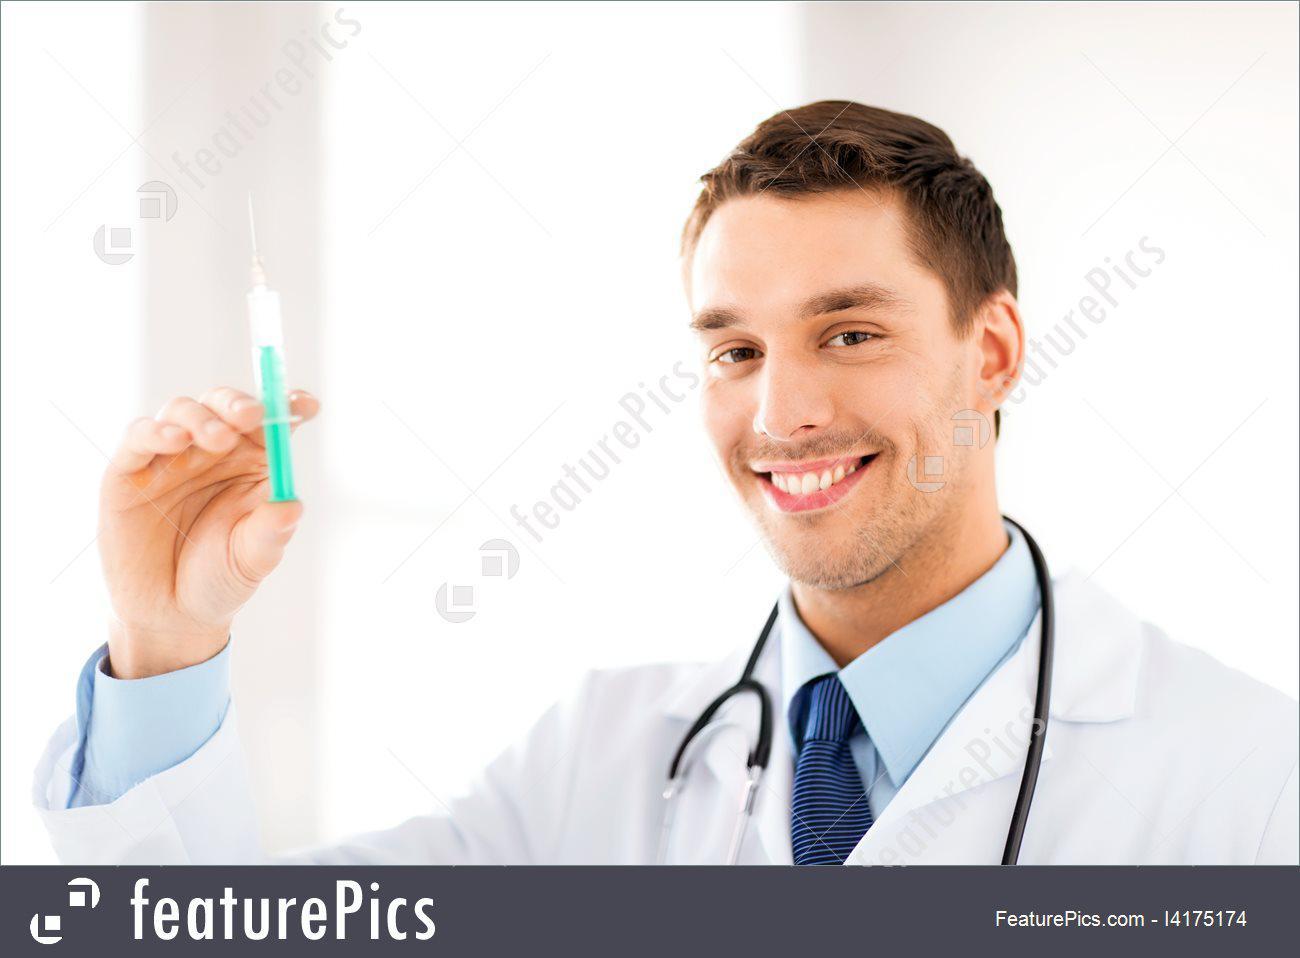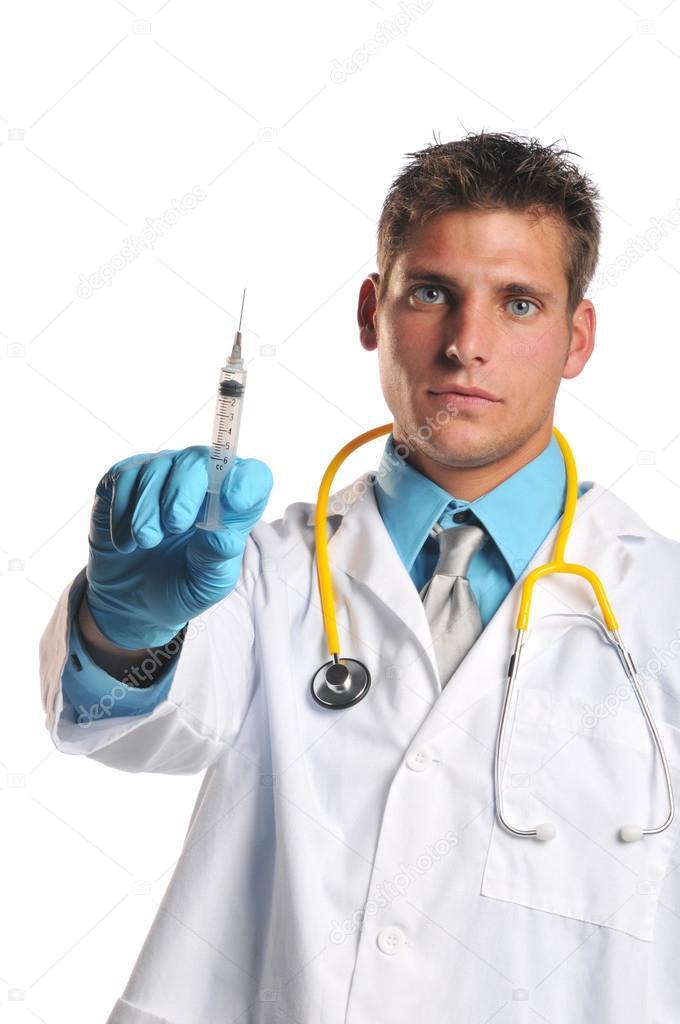The first image is the image on the left, the second image is the image on the right. Examine the images to the left and right. Is the description "In at least one of the images, a medical professional is looking directly at a syringe full of blue liquid." accurate? Answer yes or no. No. The first image is the image on the left, the second image is the image on the right. Examine the images to the left and right. Is the description "The left image shows a man holding up an aqua-colored syringe with one bare hand." accurate? Answer yes or no. Yes. 